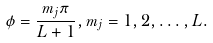<formula> <loc_0><loc_0><loc_500><loc_500>\phi = \frac { m _ { j } \pi } { L + 1 } , m _ { j } = 1 , 2 , \dots , L .</formula> 